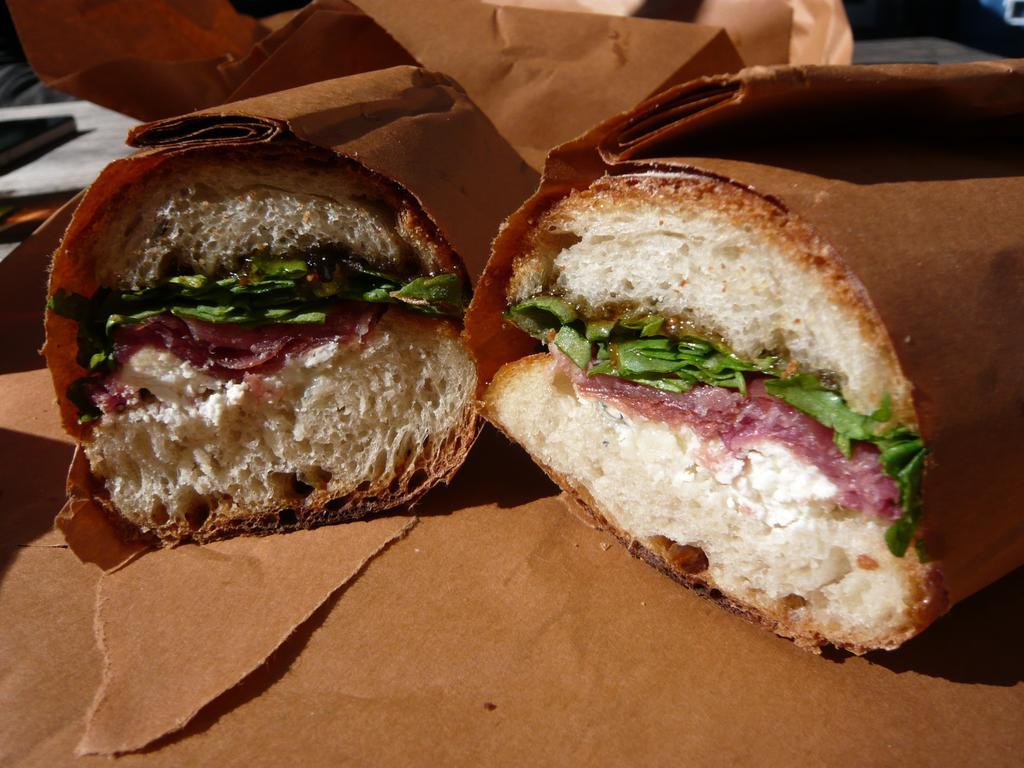Can you describe this image briefly? In this picture there is food in the brown covers. At the bottom and at the back there are brown covers and there is a book. 